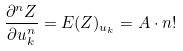Convert formula to latex. <formula><loc_0><loc_0><loc_500><loc_500>\frac { \partial ^ { n } Z } { \partial u _ { k } ^ { n } } = E ( Z ) _ { u _ { k } } = A \cdot n !</formula> 